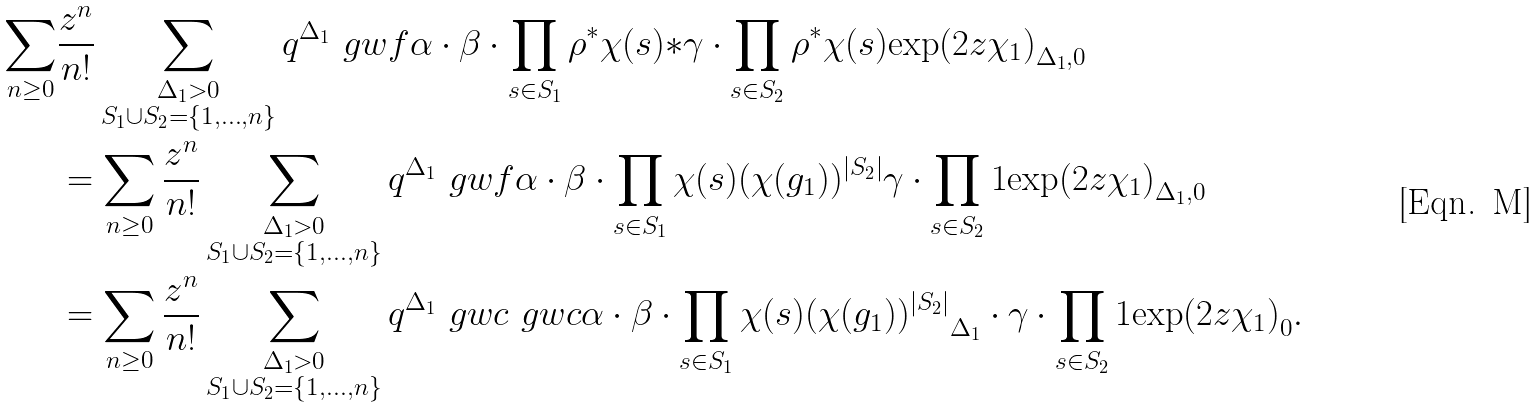Convert formula to latex. <formula><loc_0><loc_0><loc_500><loc_500>\sum _ { n \geq 0 } & \frac { z ^ { n } } { n ! } \sum _ { \substack { \Delta _ { 1 } > 0 \\ S _ { 1 } \cup S _ { 2 } = \{ 1 , \dots , n \} } } q ^ { \Delta _ { 1 } } \ g w f { \alpha \cdot \beta \cdot \prod _ { s \in S _ { 1 } } \rho ^ { * } \chi ( s ) } { * } { \gamma \cdot \prod _ { s \in S _ { 2 } } \rho ^ { * } \chi ( s ) } { \exp ( 2 z \chi _ { 1 } ) } _ { \Delta _ { 1 } , 0 } \\ & = \sum _ { n \geq 0 } \frac { z ^ { n } } { n ! } \sum _ { \substack { \Delta _ { 1 } > 0 \\ S _ { 1 } \cup S _ { 2 } = \{ 1 , \dots , n \} } } q ^ { \Delta _ { 1 } } \ g w f { \alpha \cdot \beta \cdot \prod _ { s \in S _ { 1 } } \chi ( s ) } { ( \chi ( g _ { 1 } ) ) ^ { | S _ { 2 } | } } { \gamma \cdot \prod _ { s \in S _ { 2 } } 1 } { \exp ( 2 z \chi _ { 1 } ) } _ { \Delta _ { 1 } , 0 } \\ & = \sum _ { n \geq 0 } \frac { z ^ { n } } { n ! } \sum _ { \substack { \Delta _ { 1 } > 0 \\ S _ { 1 } \cup S _ { 2 } = \{ 1 , \dots , n \} } } q ^ { \Delta _ { 1 } } \ g w c { \ g w c { \alpha \cdot \beta \cdot \prod _ { s \in S _ { 1 } } \chi ( s ) } { ( \chi ( g _ { 1 } ) ) ^ { | S _ { 2 } | } } _ { \Delta _ { 1 } } \cdot \gamma \cdot \prod _ { s \in S _ { 2 } } 1 } { \exp ( 2 z \chi _ { 1 } ) } _ { 0 } .</formula> 